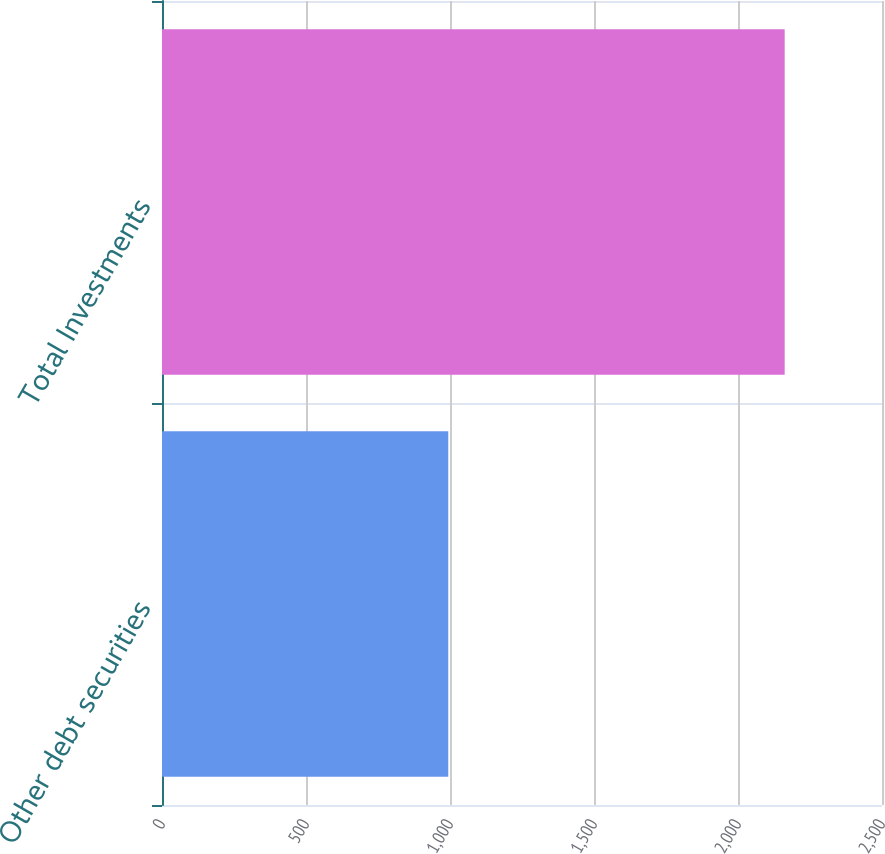Convert chart to OTSL. <chart><loc_0><loc_0><loc_500><loc_500><bar_chart><fcel>Other debt securities<fcel>Total Investments<nl><fcel>994<fcel>2162.1<nl></chart> 